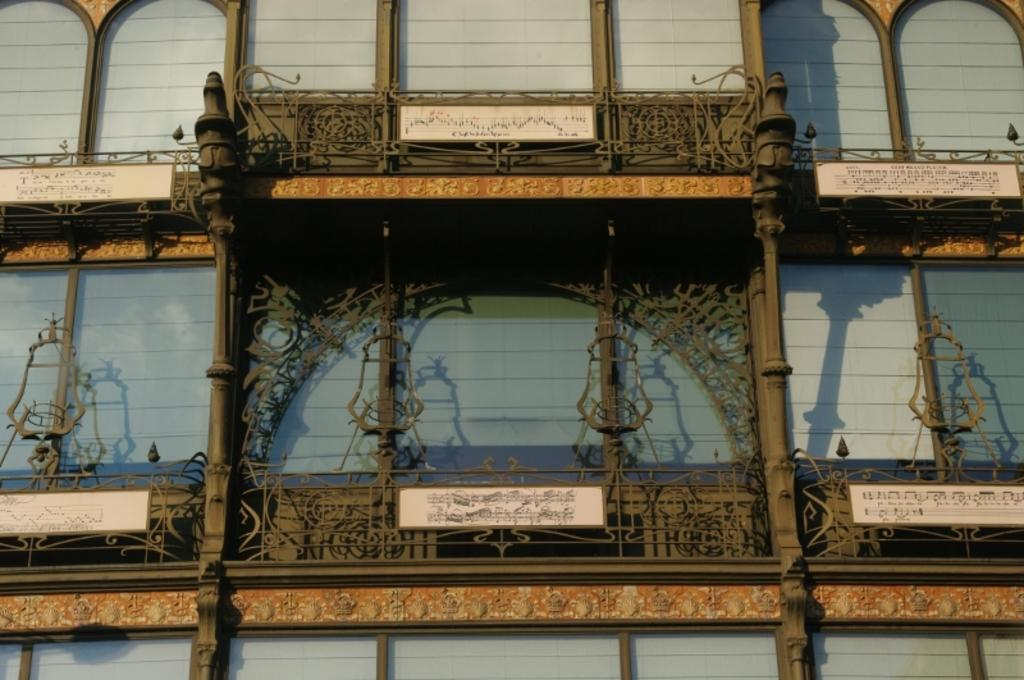What type of architectural feature can be seen in the image? There is a wall with arches in the image. What other structural elements are present in the image? There are pillars in the image. What material is used for the designs in the image? The designs are made with iron materials in the image. What can be found on the boards in the image? There are boards with writing in the image. How many bears can be seen interacting with the iron designs in the image? There are no bears present in the image; it features a wall with arches, pillars, and iron designs. What type of currency is visible on the boards with writing in the image? There is no currency visible on the boards with writing in the image. 